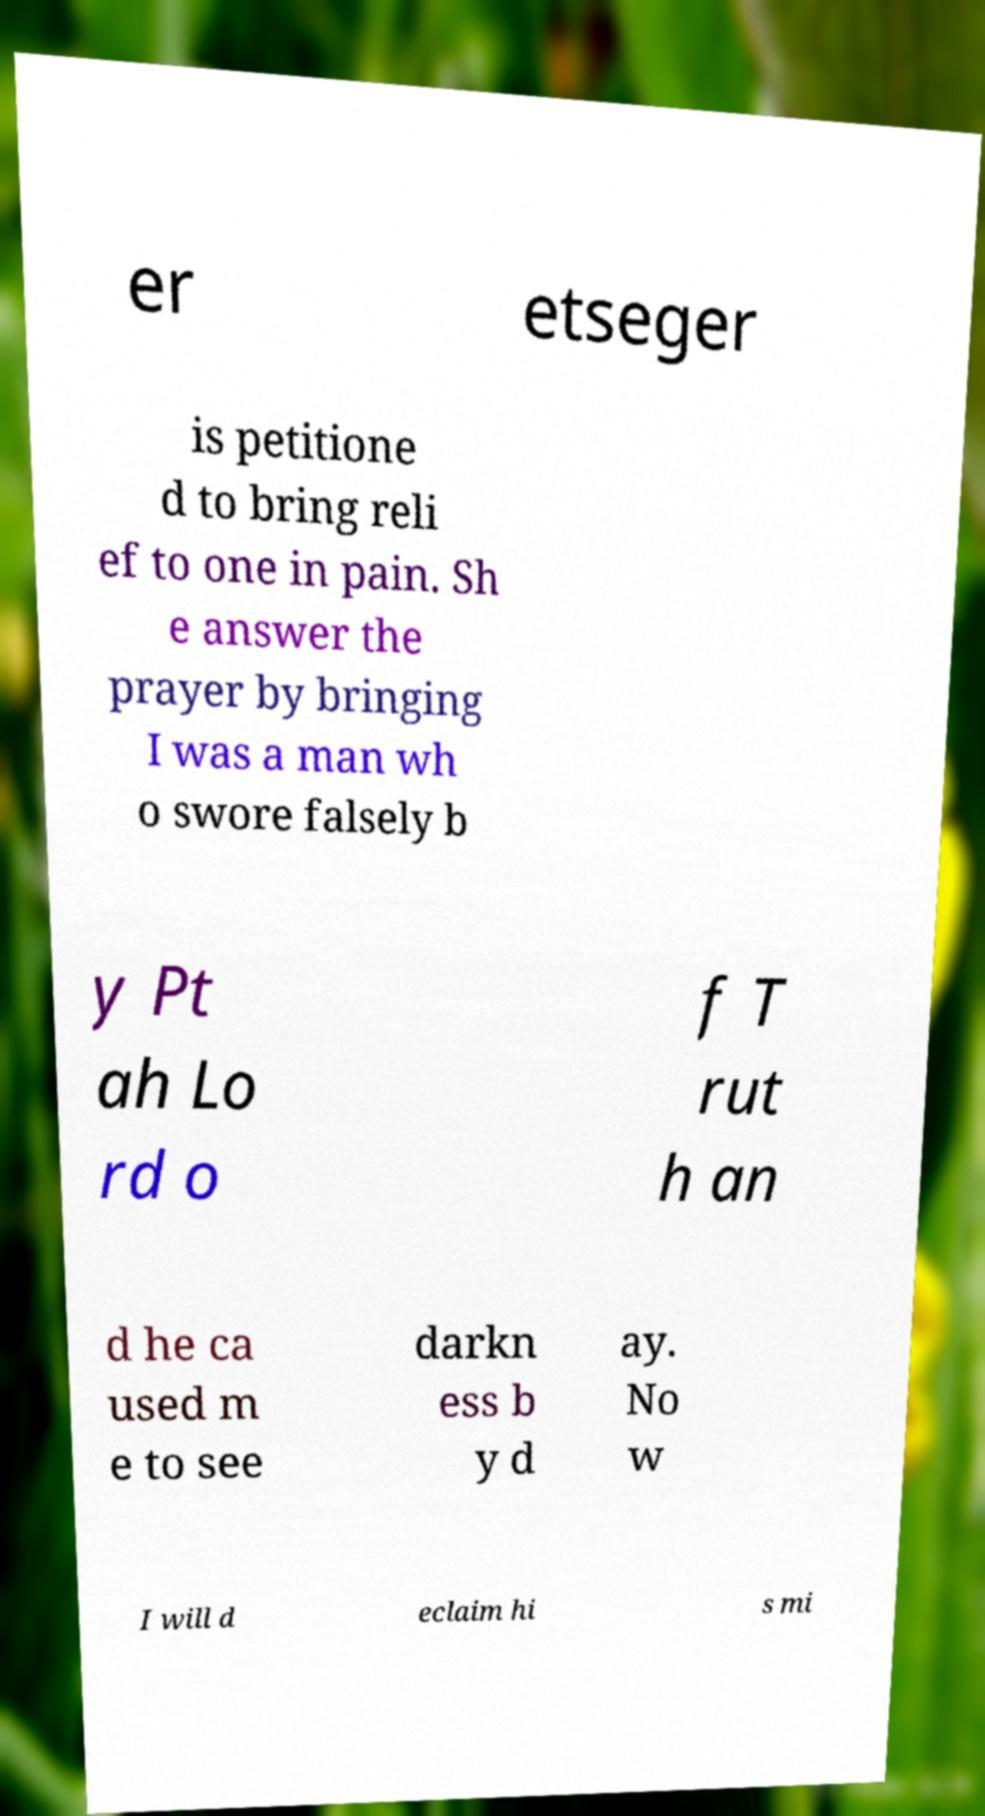Please identify and transcribe the text found in this image. er etseger is petitione d to bring reli ef to one in pain. Sh e answer the prayer by bringing I was a man wh o swore falsely b y Pt ah Lo rd o f T rut h an d he ca used m e to see darkn ess b y d ay. No w I will d eclaim hi s mi 